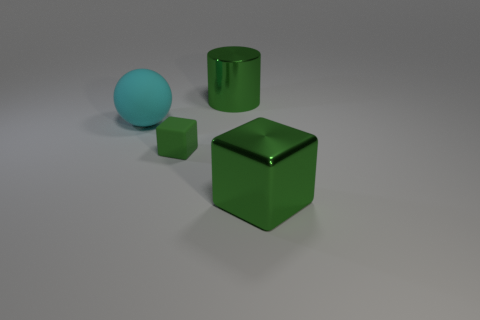Do the matte cube and the metallic object in front of the large sphere have the same color?
Provide a short and direct response. Yes. Do the small cube and the metallic cylinder have the same color?
Your answer should be compact. Yes. Is there anything else that has the same size as the green matte object?
Ensure brevity in your answer.  No. There is a green metal object that is to the right of the large metallic thing behind the green shiny cube that is on the right side of the big cyan ball; what shape is it?
Offer a terse response. Cube. What number of other things are the same color as the large ball?
Offer a very short reply. 0. What shape is the matte object to the right of the cyan matte ball that is behind the small green rubber object?
Your answer should be very brief. Cube. What number of small matte things are behind the tiny green rubber thing?
Your answer should be compact. 0. Is there a purple ball made of the same material as the big green cylinder?
Make the answer very short. No. There is a cylinder that is the same size as the rubber ball; what material is it?
Offer a very short reply. Metal. What size is the green thing that is on the left side of the metallic block and in front of the sphere?
Offer a terse response. Small. 